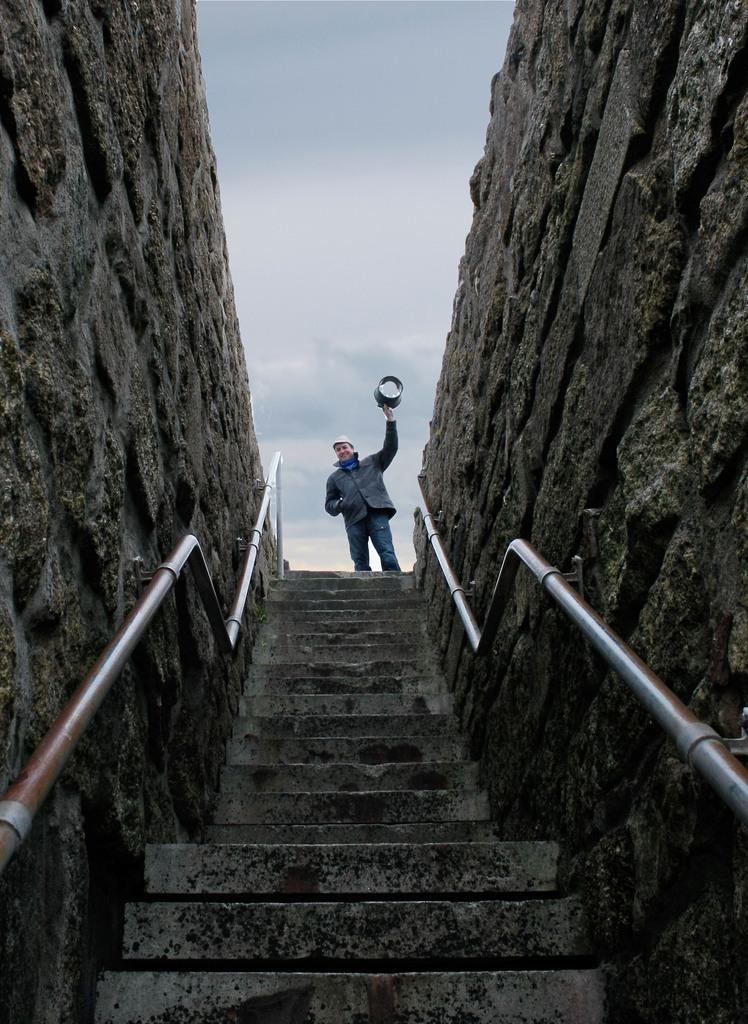What is the main subject of the image? There is a person standing in the image. What is in front of the person? There are stairs in front of the person. What else can be seen in the image besides the person and stairs? There are rods visible in the image. What is visible in the background of the image? The sky is visible in the background of the image. What type of event is taking place on the sofa in the image? There is no sofa present in the image, and therefore no event can be observed on it. 